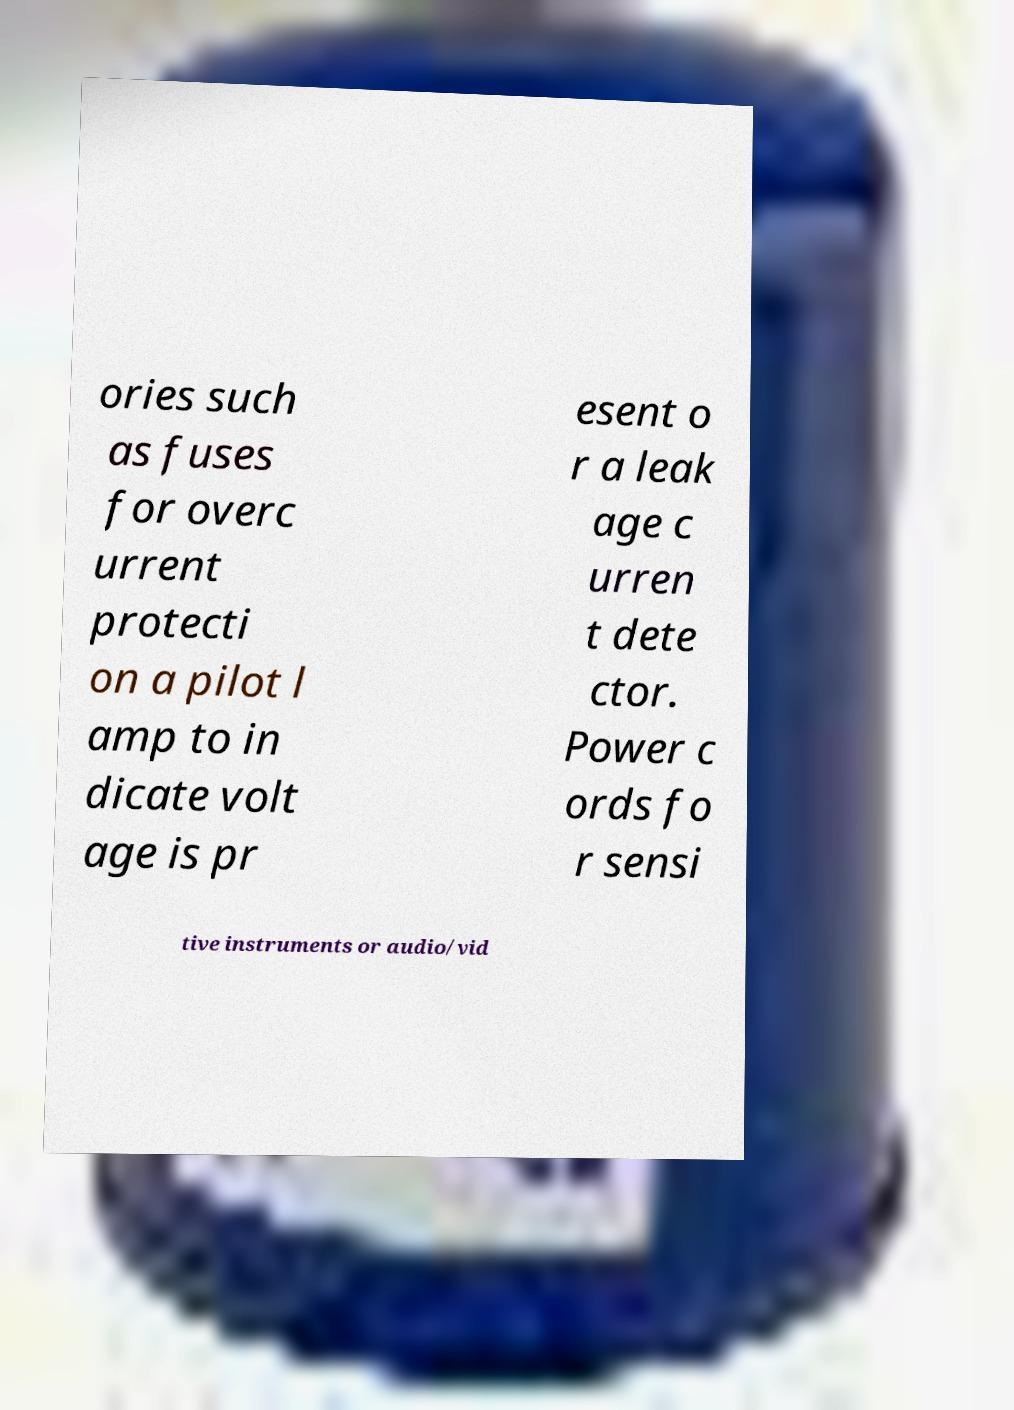Can you accurately transcribe the text from the provided image for me? ories such as fuses for overc urrent protecti on a pilot l amp to in dicate volt age is pr esent o r a leak age c urren t dete ctor. Power c ords fo r sensi tive instruments or audio/vid 